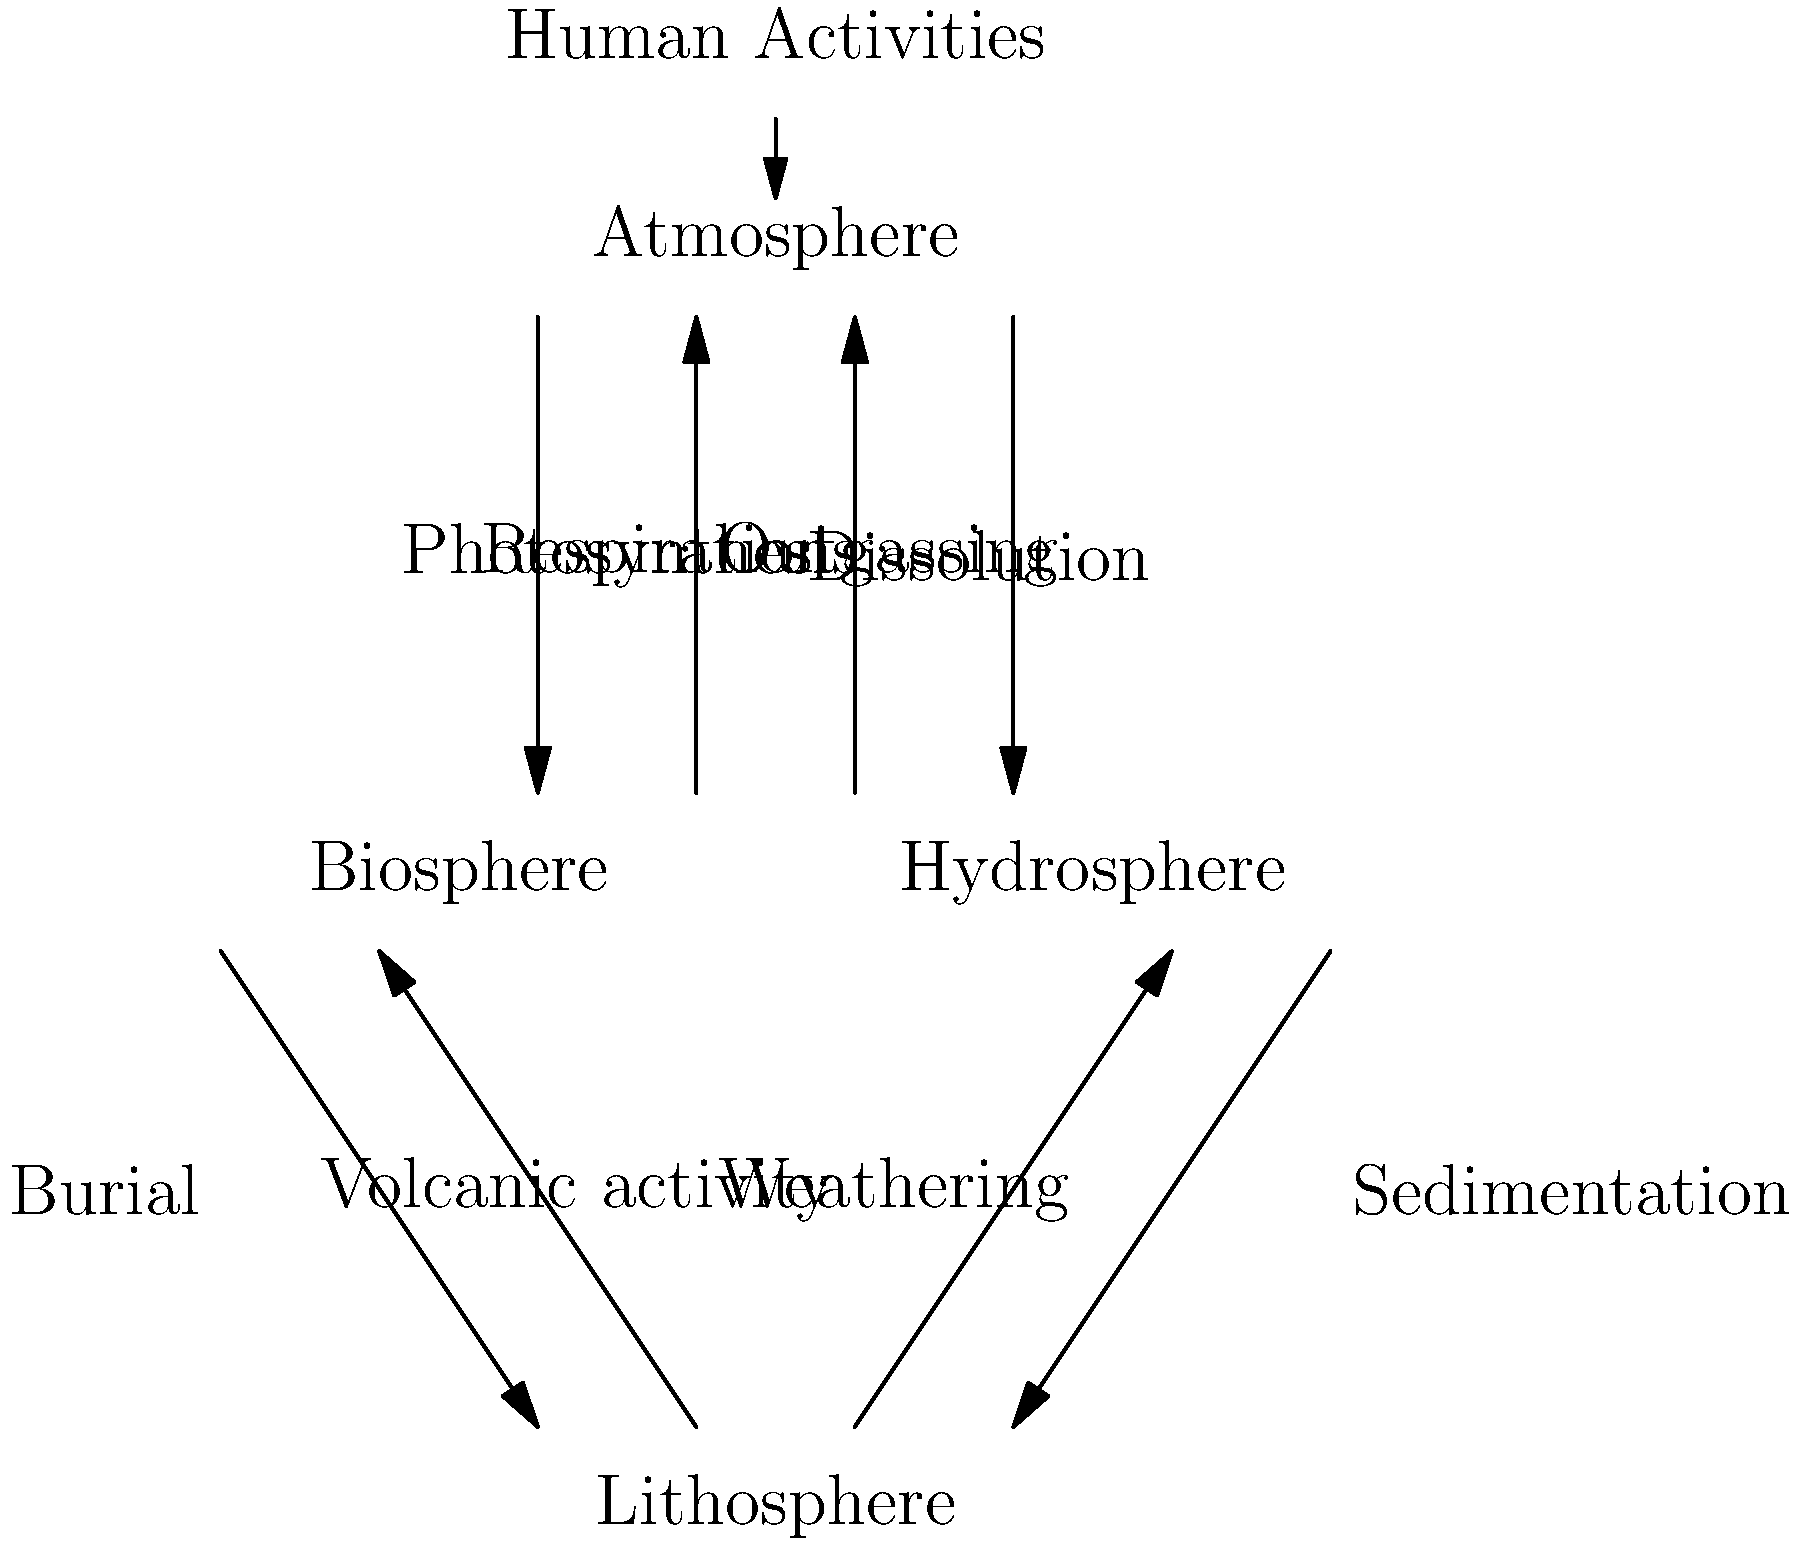As a policy maker, you're presented with this flowchart illustrating the carbon cycle and human impact. Which process in this cycle do you think would be most effectively targeted by legislation to mitigate climate change, and why? To answer this question, let's analyze the carbon cycle and human impacts step-by-step:

1. The carbon cycle involves four main reservoirs: Atmosphere, Biosphere, Hydrosphere, and Lithosphere.

2. Natural processes include:
   - Photosynthesis and respiration between atmosphere and biosphere
   - Dissolution and outgassing between atmosphere and hydrosphere
   - Burial and weathering between biosphere and lithosphere
   - Sedimentation and volcanic activity between hydrosphere and lithosphere

3. Human activities are shown to directly impact the atmosphere.

4. The most effective legislative targets would be processes that:
   a) Have a significant impact on atmospheric carbon levels
   b) Are feasible to regulate through policy

5. Considering these factors, the most effective target would be human activities affecting the atmosphere, because:
   - They directly contribute to increasing atmospheric CO2 levels
   - They are largely a result of human actions, which can be regulated
   - Many of these activities are tied to industries and practices that are already subject to legislation (e.g., energy production, transportation, deforestation)

6. Targeting natural processes would be less effective because:
   - They are part of Earth's natural balance and are harder to control
   - Interfering with these processes could have unintended consequences on ecosystems

7. Legislation could focus on:
   - Reducing emissions from fossil fuel combustion
   - Promoting renewable energy sources
   - Encouraging reforestation and sustainable land use practices
   - Implementing carbon pricing or cap-and-trade systems
Answer: Human activities affecting the atmosphere 